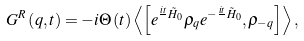<formula> <loc_0><loc_0><loc_500><loc_500>G ^ { R } \left ( q , t \right ) = - i \Theta \left ( t \right ) \left \langle \left [ e ^ { \frac { i t } { } \tilde { H } _ { 0 } } \rho _ { q } e ^ { - \frac { i t } { } \tilde { H } _ { 0 } } , \rho _ { - q } \right ] \right \rangle ,</formula> 